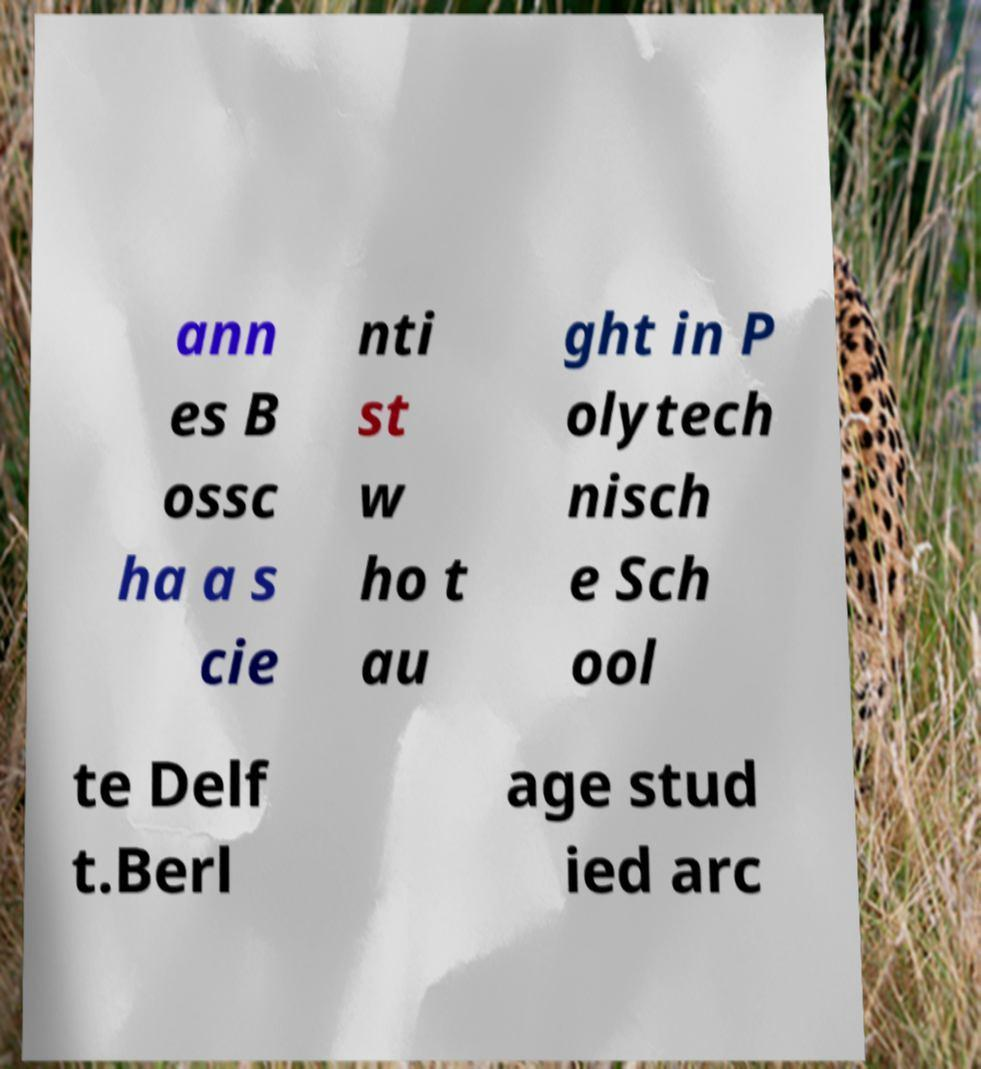Can you read and provide the text displayed in the image?This photo seems to have some interesting text. Can you extract and type it out for me? ann es B ossc ha a s cie nti st w ho t au ght in P olytech nisch e Sch ool te Delf t.Berl age stud ied arc 